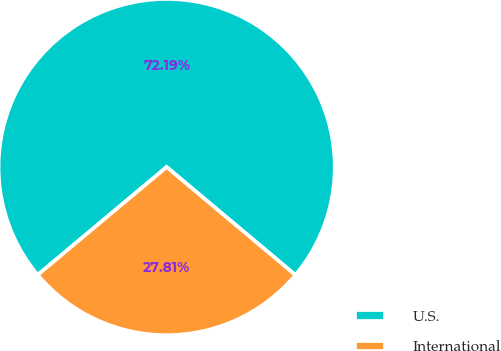<chart> <loc_0><loc_0><loc_500><loc_500><pie_chart><fcel>U.S.<fcel>International<nl><fcel>72.19%<fcel>27.81%<nl></chart> 